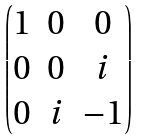Convert formula to latex. <formula><loc_0><loc_0><loc_500><loc_500>\begin{pmatrix} 1 & 0 & 0 \\ 0 & 0 & i \\ 0 & i & - 1 \end{pmatrix}</formula> 